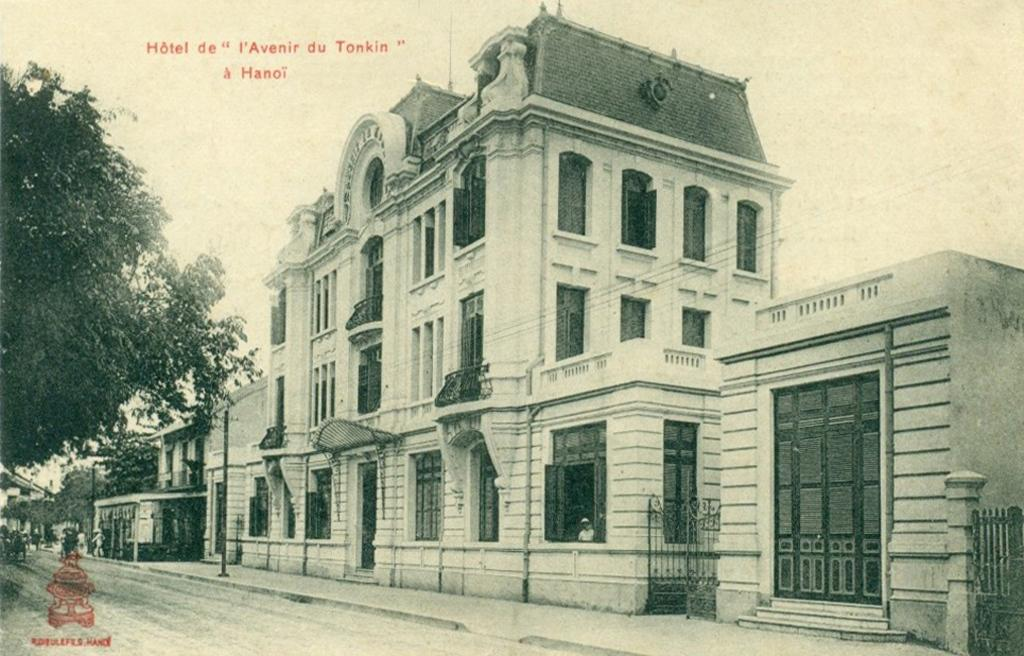What type of structure is in the image? There is a building in the image. What color is the building? The building is white. What feature can be seen on the building? The building has windows. What is located on the left side of the image? There is a tree on the left side of the image. What is at the bottom of the image? There is a road at the bottom of the image. What is visible at the top of the image? There is text visible at the top of the image. What type of skirt is hanging from the tree in the image? There is no skirt hanging from the tree in the image; it is a tree with no clothing items present. 